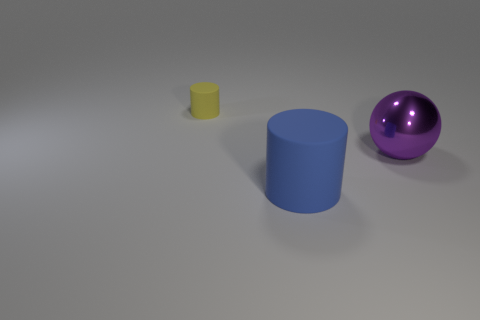Add 1 large blue objects. How many objects exist? 4 Subtract all spheres. How many objects are left? 2 Subtract all big blue cylinders. Subtract all large spheres. How many objects are left? 1 Add 2 large cylinders. How many large cylinders are left? 3 Add 1 small blue metal blocks. How many small blue metal blocks exist? 1 Subtract 0 red balls. How many objects are left? 3 